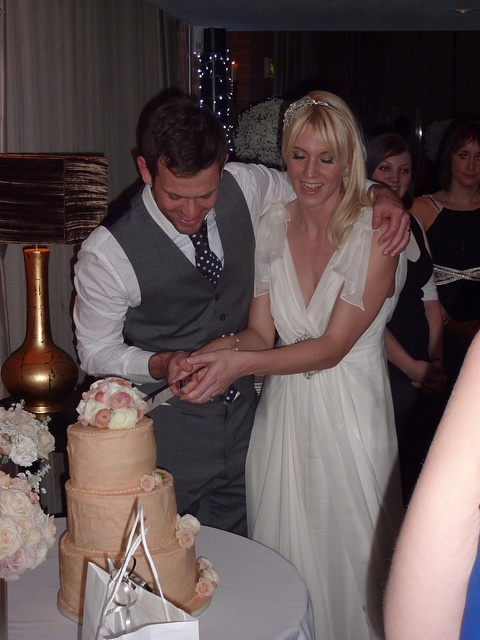Describe the objects in this image and their specific colors. I can see people in black, darkgray, and gray tones, people in black, darkgray, gray, and maroon tones, cake in black, gray, tan, and darkgray tones, people in black, pink, and darkgray tones, and people in black, maroon, gray, and brown tones in this image. 